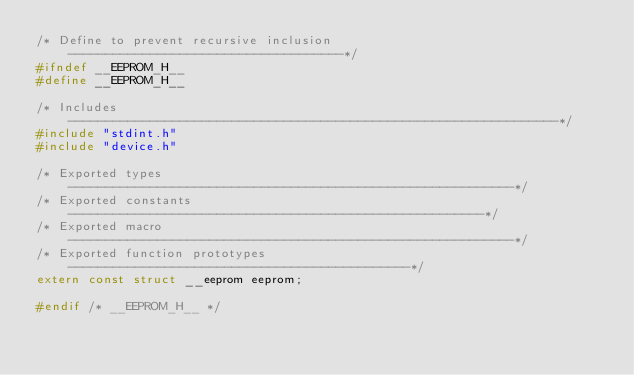Convert code to text. <code><loc_0><loc_0><loc_500><loc_500><_C_>/* Define to prevent recursive inclusion -------------------------------------*/
#ifndef __EEPROM_H__
#define __EEPROM_H__

/* Includes ------------------------------------------------------------------*/
#include "stdint.h"
#include "device.h"

/* Exported types ------------------------------------------------------------*/
/* Exported constants --------------------------------------------------------*/
/* Exported macro ------------------------------------------------------------*/
/* Exported function prototypes ----------------------------------------------*/
extern const struct __eeprom eeprom;

#endif /* __EEPROM_H__ */
</code> 